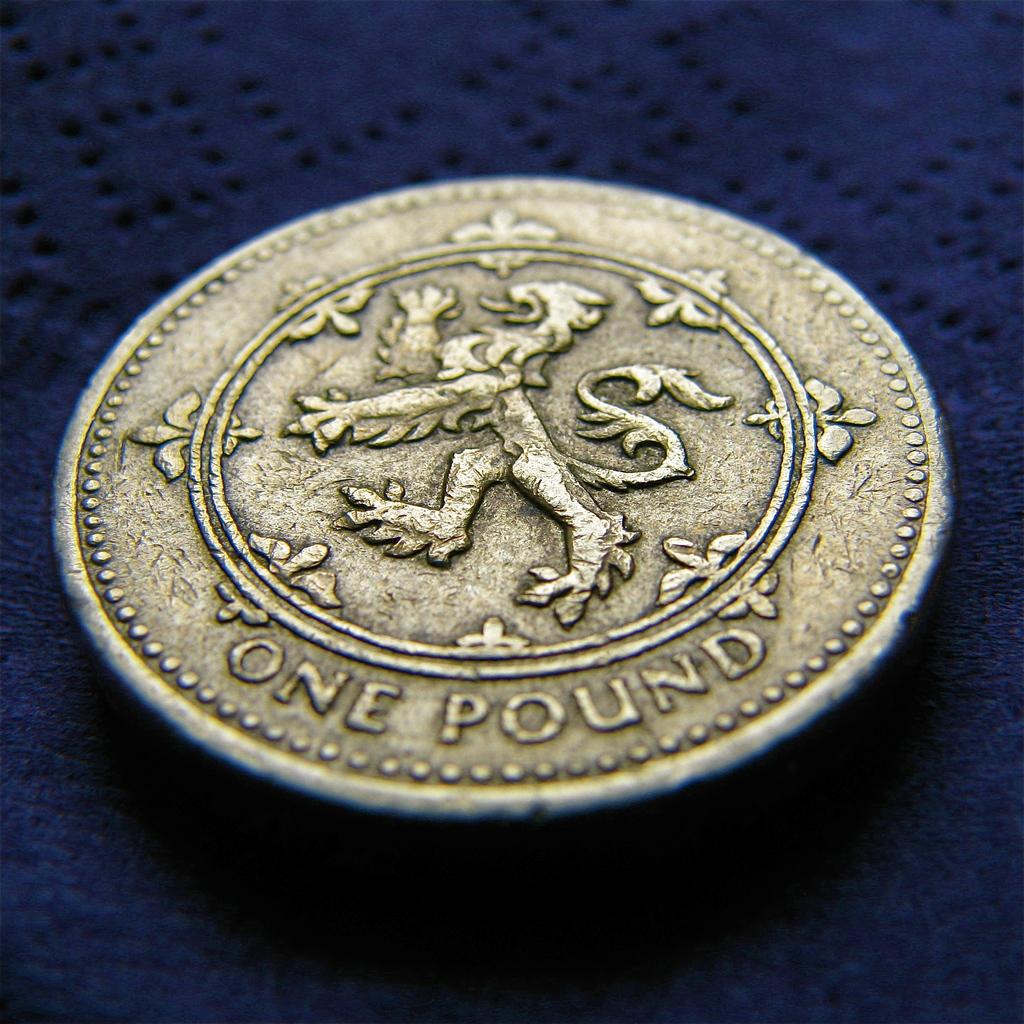How many pounds?
Ensure brevity in your answer.  One. 